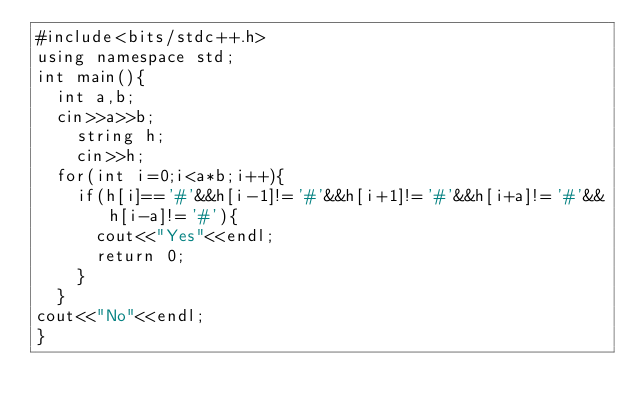Convert code to text. <code><loc_0><loc_0><loc_500><loc_500><_C++_>#include<bits/stdc++.h>
using namespace std;
int main(){
  int a,b;
  cin>>a>>b;
    string h;
    cin>>h;
  for(int i=0;i<a*b;i++){
    if(h[i]=='#'&&h[i-1]!='#'&&h[i+1]!='#'&&h[i+a]!='#'&&h[i-a]!='#'){
      cout<<"Yes"<<endl;
      return 0;
    }
  }
cout<<"No"<<endl;
}
</code> 